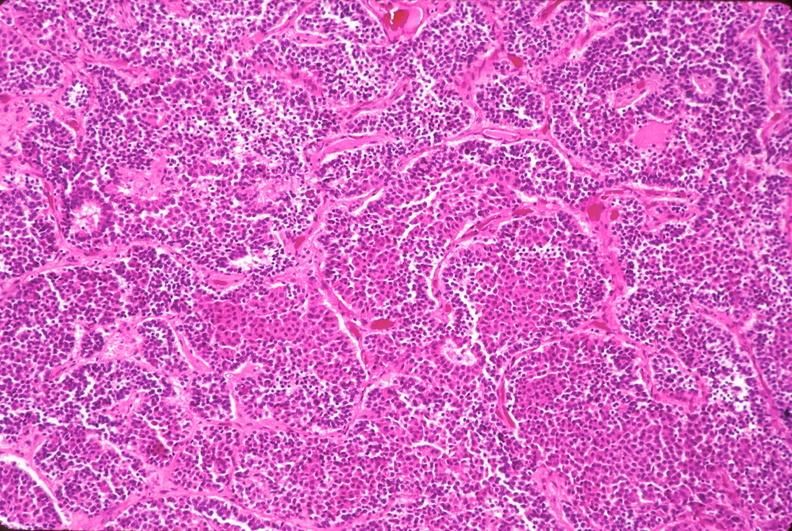does pus in test tube show pituitary, chromaphobe adenoma?
Answer the question using a single word or phrase. No 